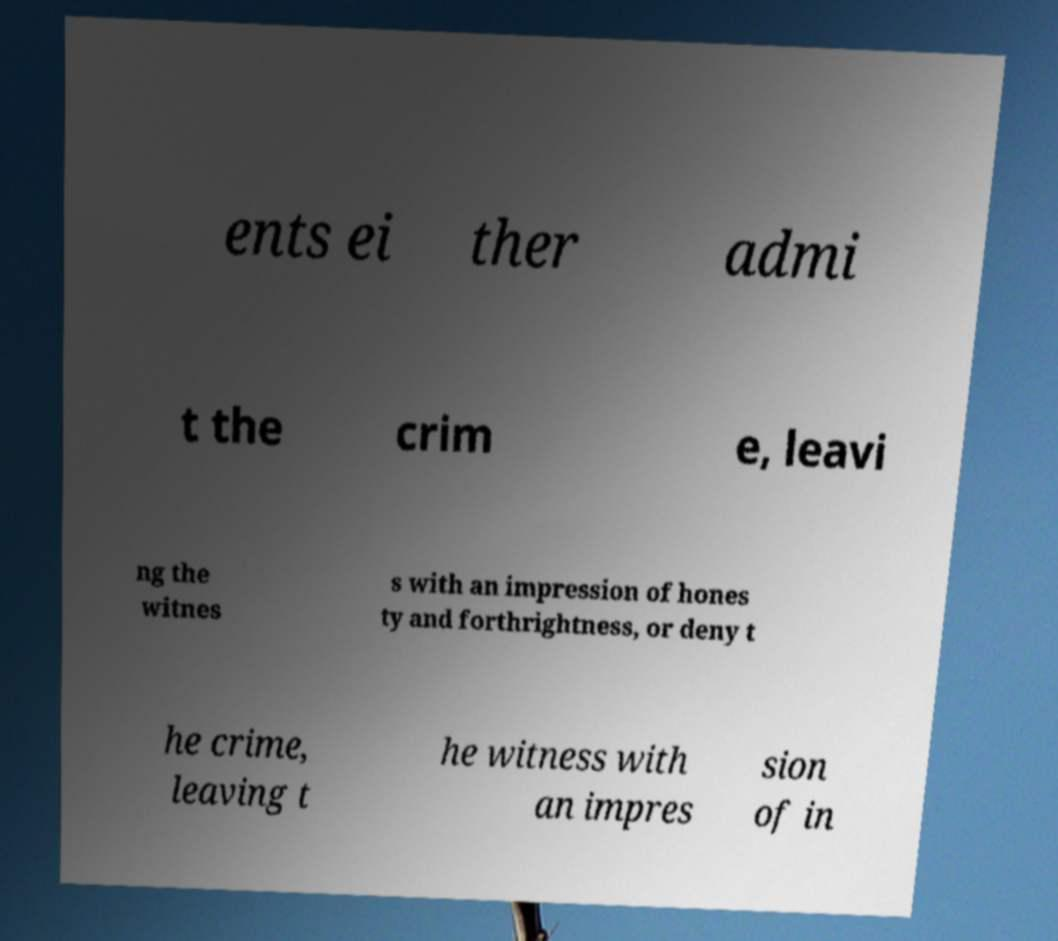Please read and relay the text visible in this image. What does it say? ents ei ther admi t the crim e, leavi ng the witnes s with an impression of hones ty and forthrightness, or deny t he crime, leaving t he witness with an impres sion of in 